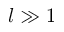Convert formula to latex. <formula><loc_0><loc_0><loc_500><loc_500>l \gg 1</formula> 